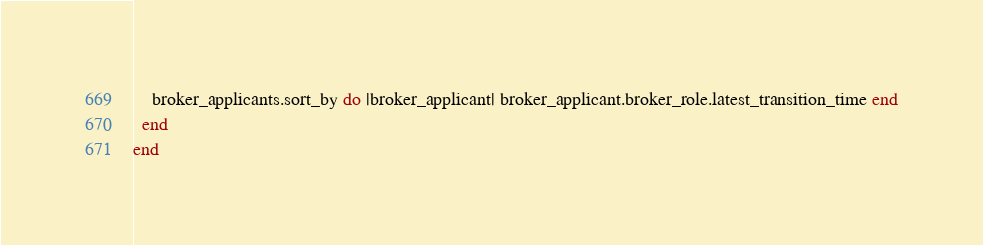<code> <loc_0><loc_0><loc_500><loc_500><_Ruby_>    broker_applicants.sort_by do |broker_applicant| broker_applicant.broker_role.latest_transition_time end
  end
end</code> 